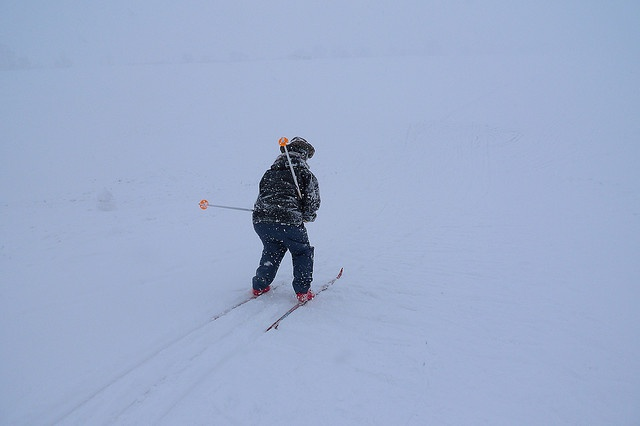Describe the objects in this image and their specific colors. I can see people in darkgray, black, and gray tones and skis in darkgray and gray tones in this image. 